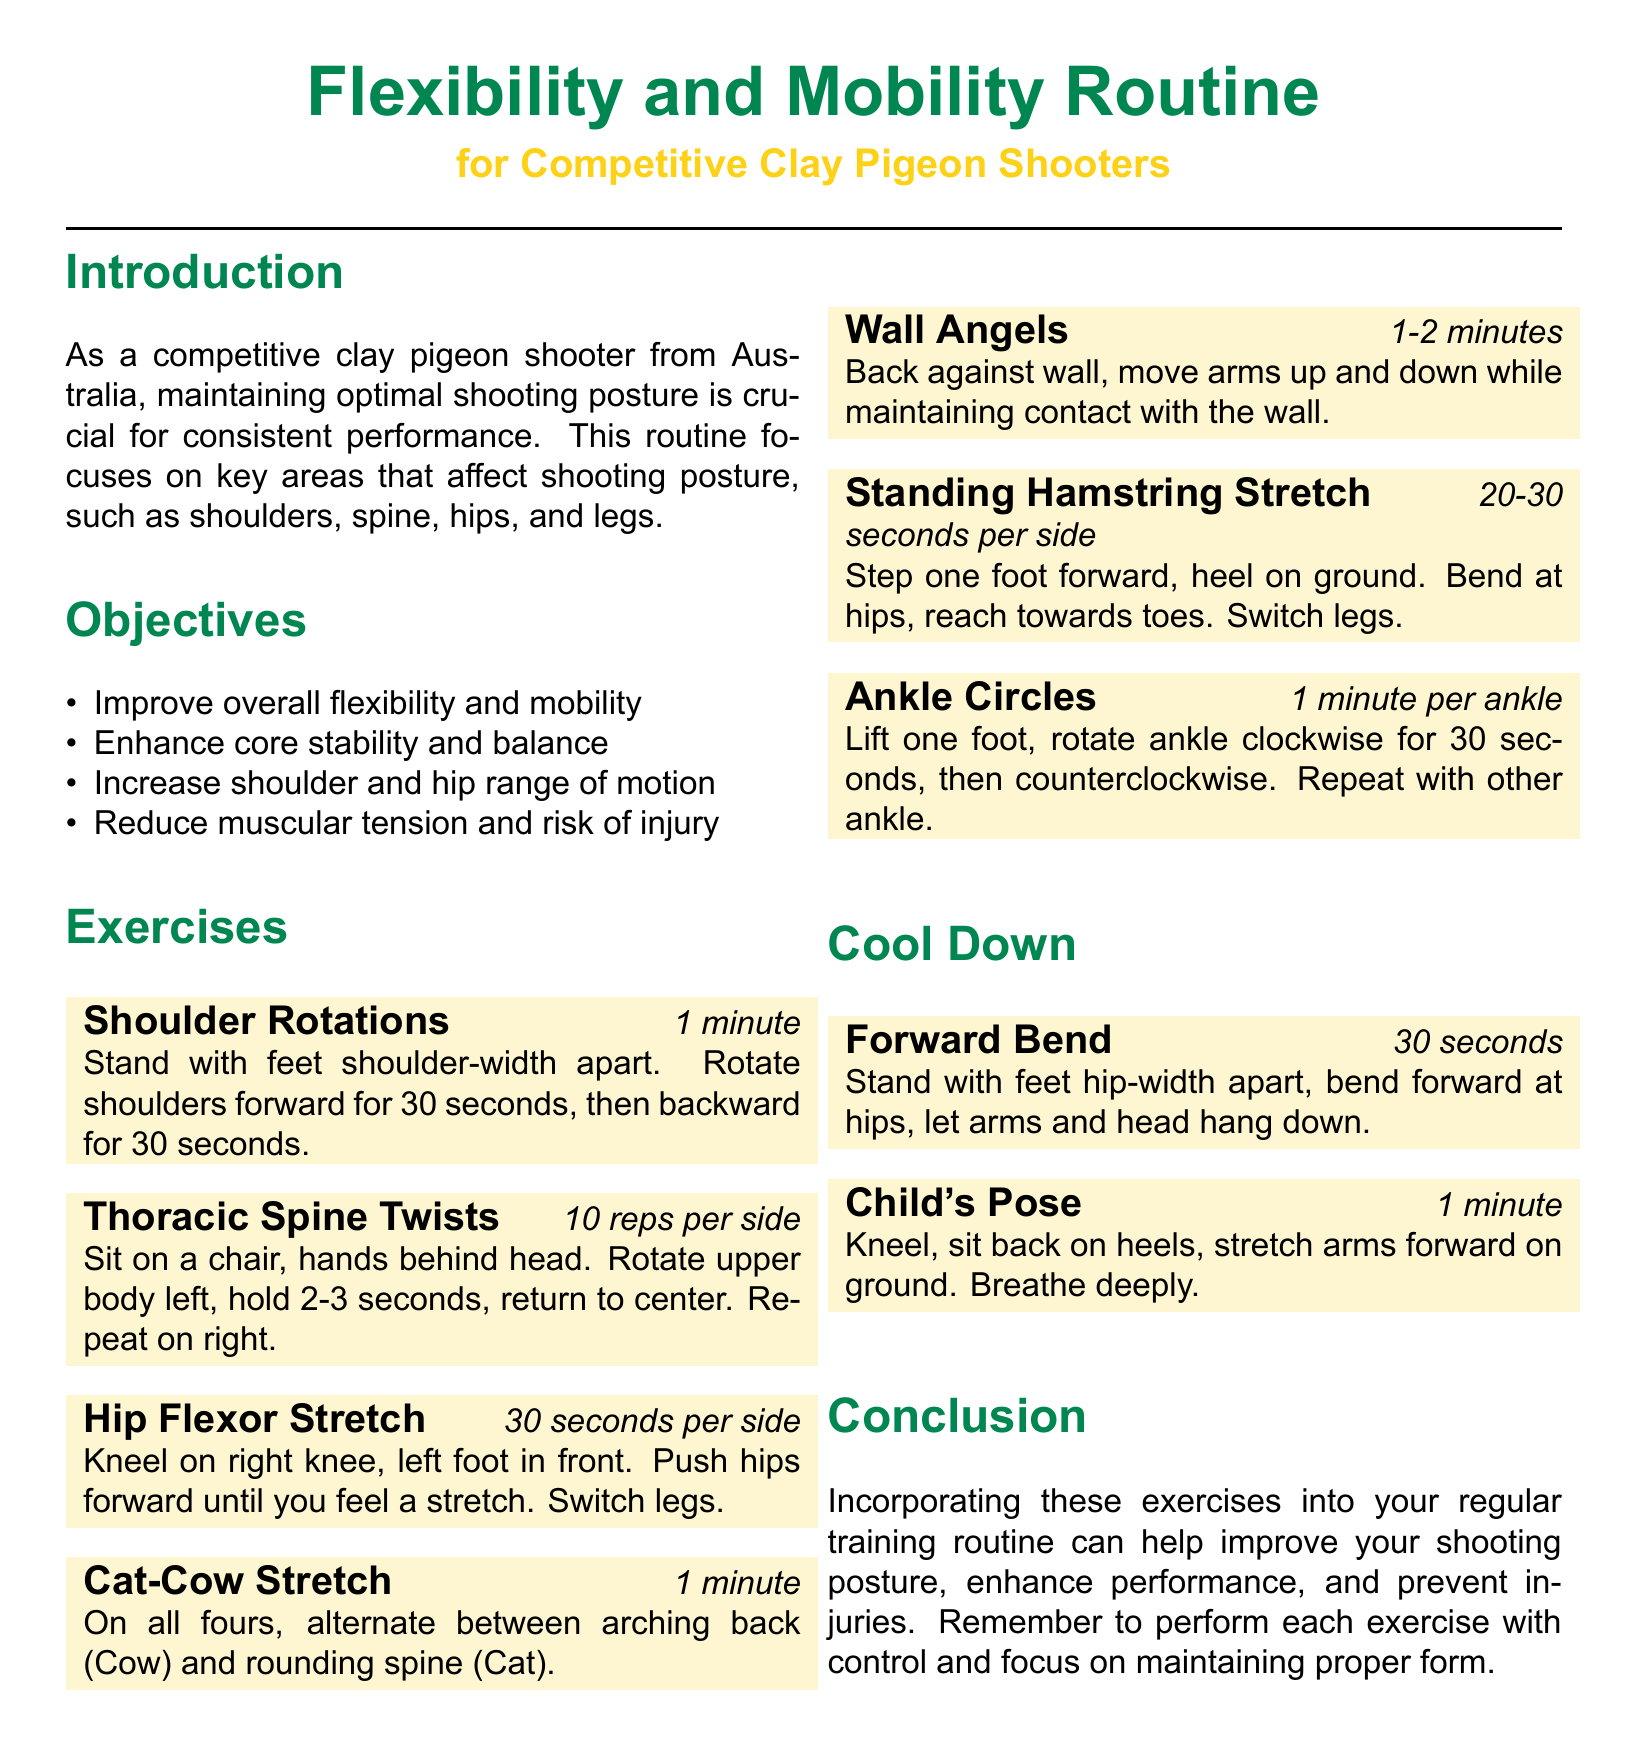What is the title of the routine? The title of the routine is presented in large font at the top of the document.
Answer: Flexibility and Mobility Routine Who is the routine intended for? The document specifies the target audience in the subtitle.
Answer: Competitive Clay Pigeon Shooters How long should the Wall Angels exercise last? The duration of the Wall Angels exercise is indicated in the exercise block.
Answer: 1-2 minutes What is the total number of repetitions for the Thoracic Spine Twists? The document outlines the number of repetitions required for this exercise.
Answer: 10 reps per side Which exercise involves arching and rounding the back? This exercise name is specifically stated in the document.
Answer: Cat-Cow Stretch What is the primary objective of the program? The objectives are listed in the objective section of the document, specifically the first one.
Answer: Improve overall flexibility and mobility How long should one hold the Hip Flexor Stretch? The document specifies the duration for this stretch in the exercise block.
Answer: 30 seconds per side What is the final exercise listed for cool down? The cool-down section describes the last exercise in that part.
Answer: Child's Pose 